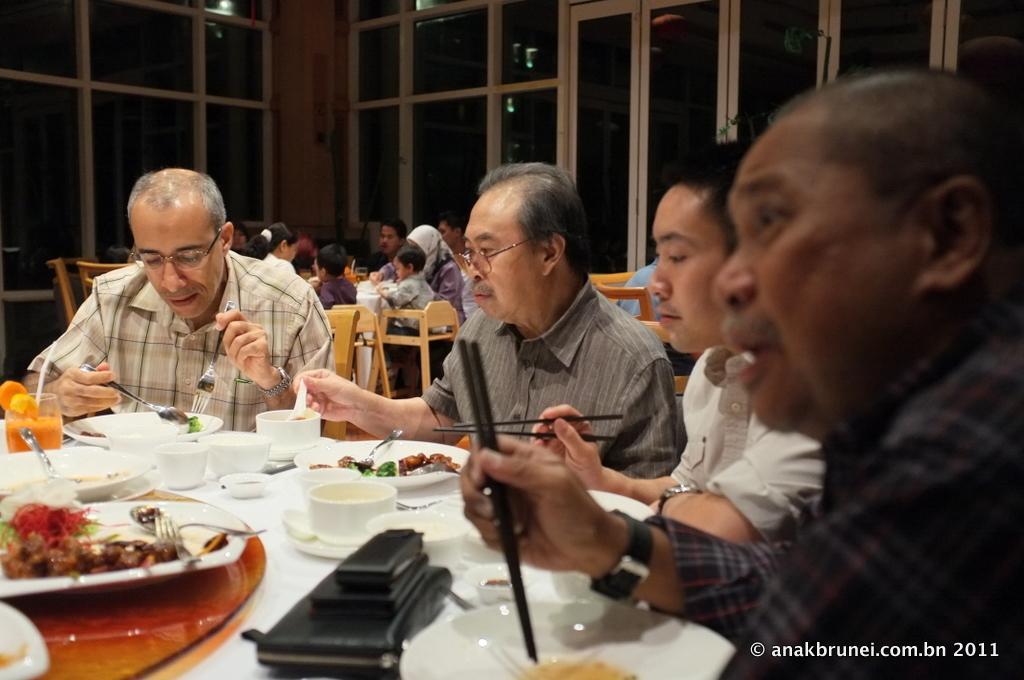Describe this image in one or two sentences. In this image I can see the plates and bowls on the table. I can see some people. In the background, I can see the windows. 